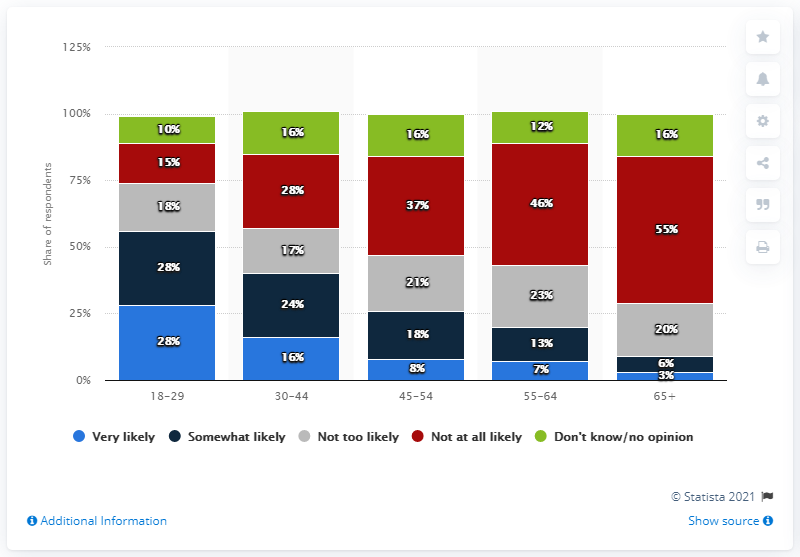Draw attention to some important aspects in this diagram. A survey found that 28% of 18-29-year-olds stated that they were extremely likely to watch the "Mulan" movie in theaters. For those aged 65 and above, 91% are either very likely or somewhat likely to use digital tools to access their health information, according to the survey. According to the data, 28% of 18-29-year-olds stated that they were extremely likely to watch the "Mulan" movie in theaters. The response segment with the lowest volume is very likely the one with only 3%. 